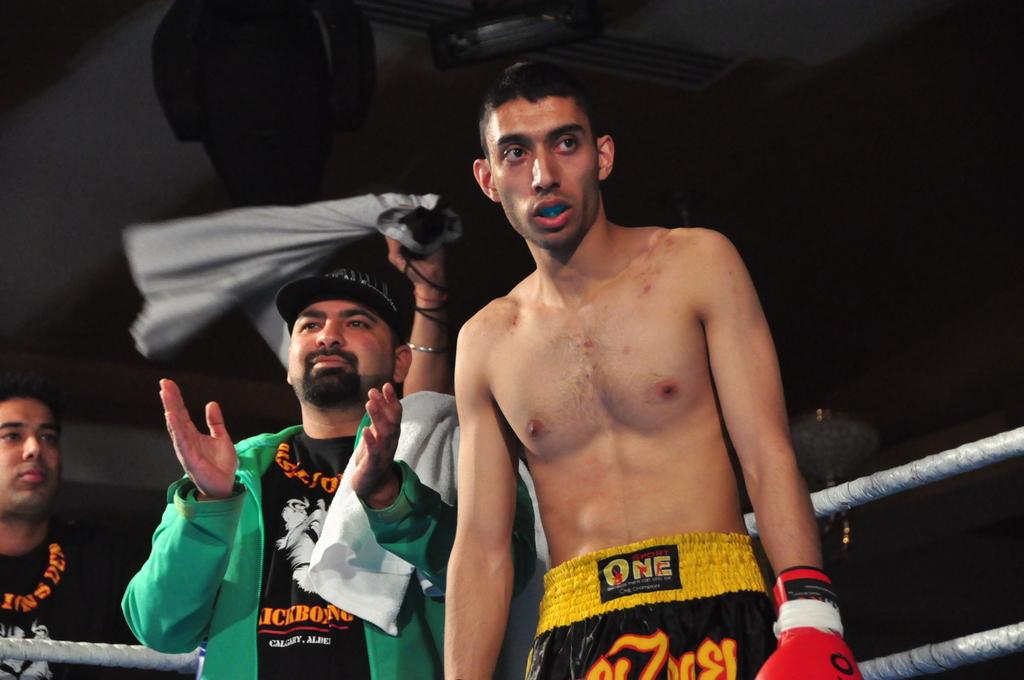<image>
Create a compact narrative representing the image presented. A man is shirtless in boxing gear that reads Sport One 